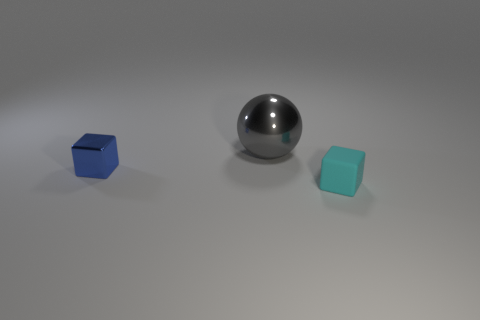Is there any other thing that has the same size as the gray shiny object?
Keep it short and to the point. No. How many tiny blue rubber balls are there?
Provide a short and direct response. 0. What number of things are behind the cyan thing and in front of the large gray metallic sphere?
Your answer should be compact. 1. Is there anything else that has the same shape as the big thing?
Give a very brief answer. No. The shiny object that is in front of the big sphere has what shape?
Your answer should be compact. Cube. How many other objects are there of the same material as the tiny blue block?
Keep it short and to the point. 1. What material is the small blue thing?
Offer a terse response. Metal. How many big things are either spheres or matte blocks?
Your answer should be compact. 1. How many blue objects are behind the cyan block?
Make the answer very short. 1. What number of green things are small objects or metallic things?
Provide a succinct answer. 0. 